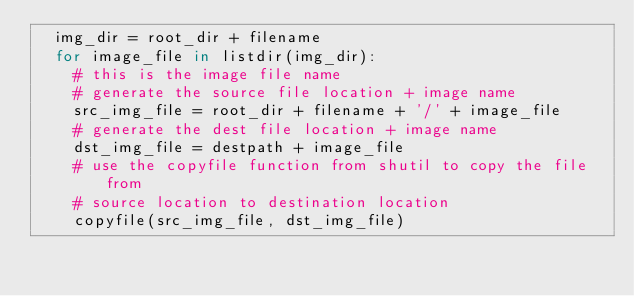Convert code to text. <code><loc_0><loc_0><loc_500><loc_500><_Python_>	img_dir = root_dir + filename
	for image_file in listdir(img_dir):
		# this is the image file name
		# generate the source file location + image name
		src_img_file = root_dir + filename + '/' + image_file
		# generate the dest file location + image name
		dst_img_file = destpath + image_file
		# use the copyfile function from shutil to copy the file from
		# source location to destination location
		copyfile(src_img_file, dst_img_file)</code> 